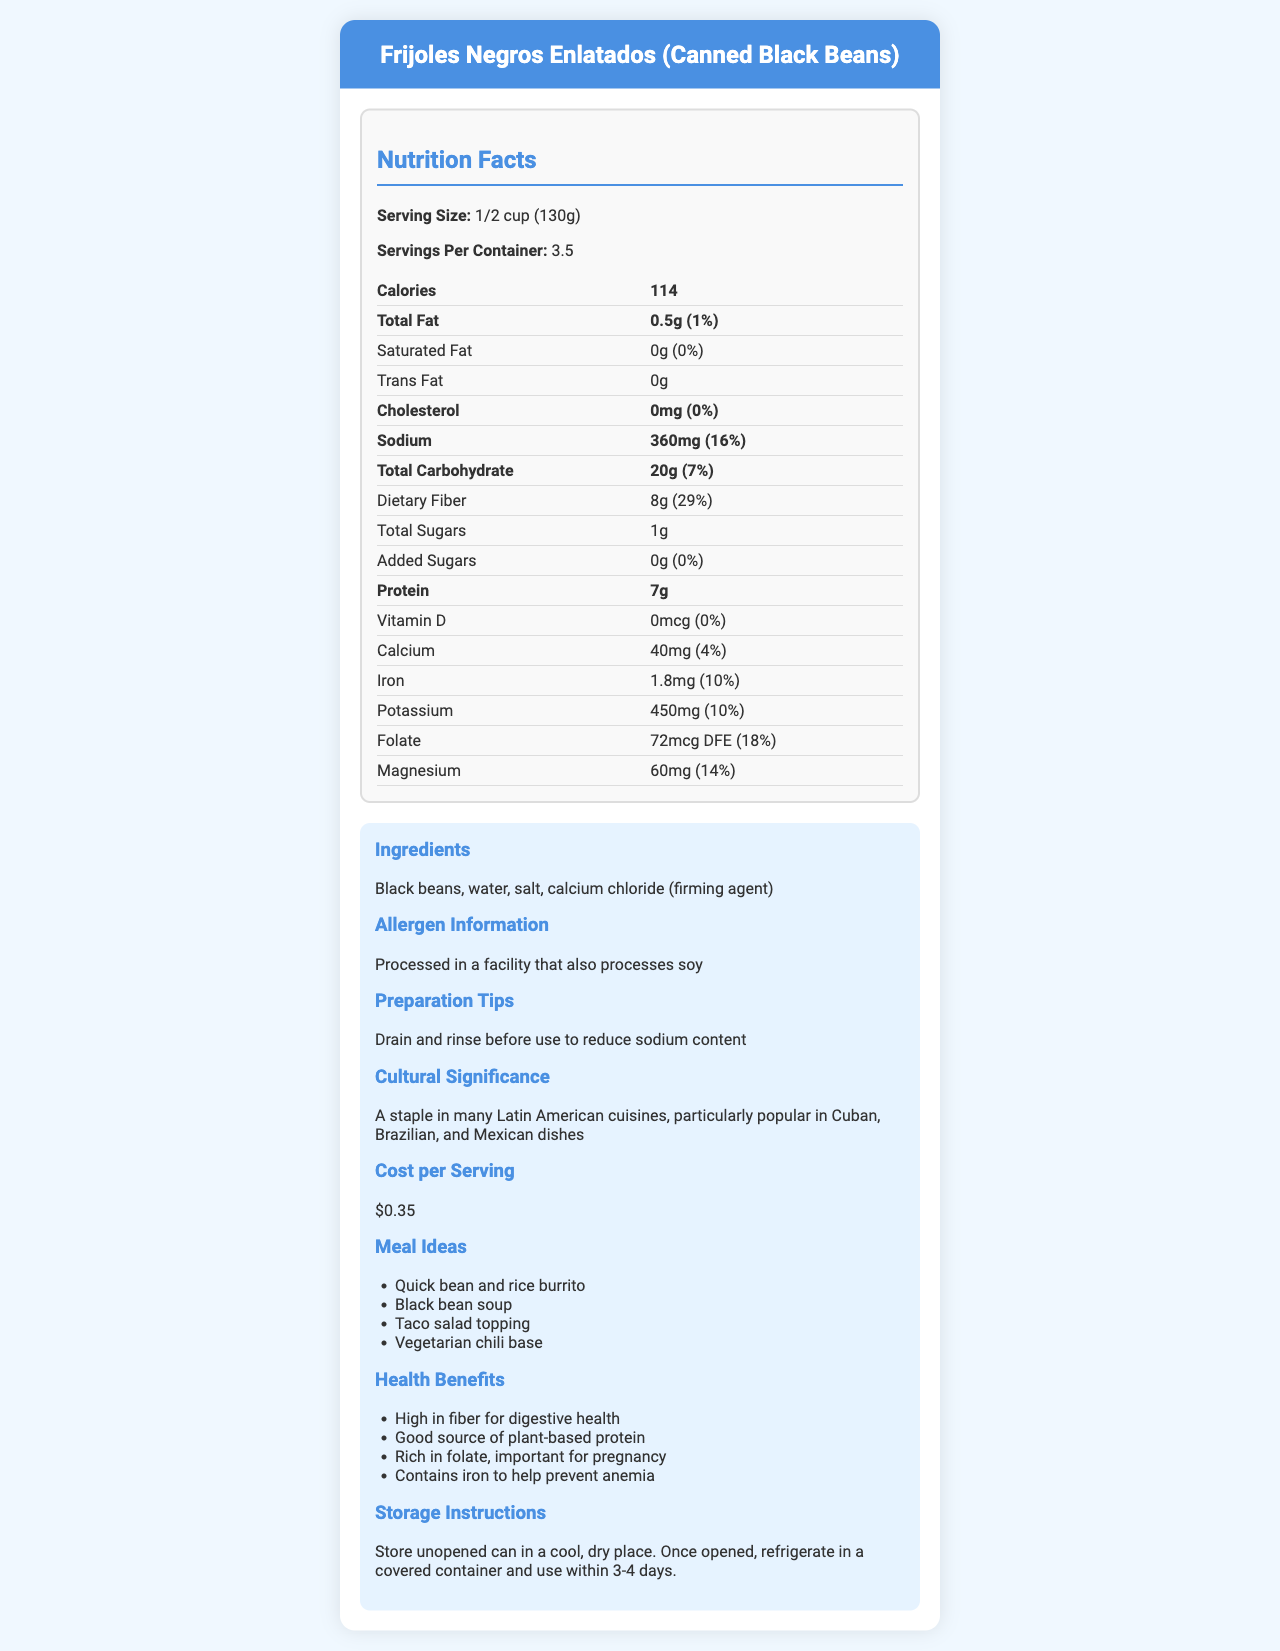How many calories are in one serving of Canned Black Beans? According to the nutrition facts, one serving (1/2 cup or 130g) of Canned Black Beans contains 114 calories.
Answer: 114 calories How much dietary fiber is in one serving, and what percentage of the daily value does it represent? The nutrition facts state that one serving contains 8g of dietary fiber, which represents 29% of the daily value.
Answer: 8g, 29% How much sodium is in one serving? The nutrition facts indicate that one serving of Canned Black Beans contains 360mg of sodium.
Answer: 360mg What are the main ingredients of Canned Black Beans? The ingredients listed are Black beans, water, salt, and calcium chloride (firming agent).
Answer: Black beans, water, salt, calcium chloride (firming agent) Which vitamin is completely absent from Canned Black Beans? According to the nutrition facts, Canned Black Beans have 0mcg of Vitamin D, which is 0% of the daily value.
Answer: Vitamin D Where should unopened cans be stored? The storage instructions state that unopened cans should be stored in a cool, dry place.
Answer: In a cool, dry place What is the cost per serving of this product? The cost per serving is listed as $0.35 in the additional information section.
Answer: $0.35 What cultural cuisines commonly include Canned Black Beans? A. Mediterranean B. Latin American C. Asian D. Italian The document states that Canned Black Beans are a staple in many Latin American cuisines.
Answer: B Based on the nutrition facts, which of the following nutrients is the highest in one serving? A. Protein B. Dietary Fiber C. Iron D. Magnesium The nutrients are: Protein 7g, Dietary Fiber 8g, Iron 1.8mg, Magnesium 60mg. Therefore, Dietary Fiber is the highest.
Answer: B Are Canned Black Beans a good source of plant-based protein? The health benefits section mentions that Canned Black Beans are a good source of plant-based protein.
Answer: Yes Please describe the main idea of the document. This summary covers the diverse aspects and information provided in the document about the Canned Black Beans product.
Answer: The document provides comprehensive information about Canned Black Beans, including nutrition facts, ingredients, cultural significance, cost, preparation tips, health benefits, and storage instructions. It highlights the product's affordability, nutritional value, and its relevance in Latin American cuisine. Can you use Canned Black Beans for baking purposes? The document does not provide any specific information about using Canned Black Beans for baking purposes.
Answer: Not enough information 